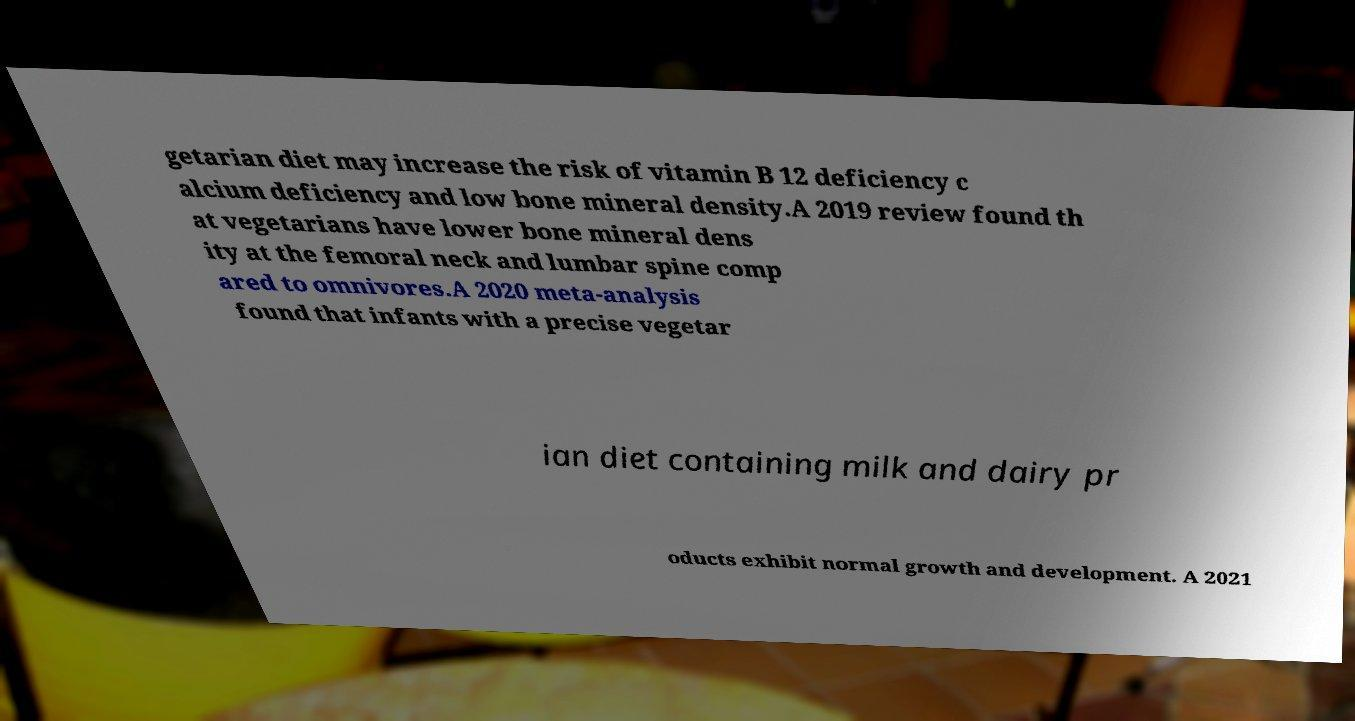Can you read and provide the text displayed in the image?This photo seems to have some interesting text. Can you extract and type it out for me? getarian diet may increase the risk of vitamin B 12 deficiency c alcium deficiency and low bone mineral density.A 2019 review found th at vegetarians have lower bone mineral dens ity at the femoral neck and lumbar spine comp ared to omnivores.A 2020 meta-analysis found that infants with a precise vegetar ian diet containing milk and dairy pr oducts exhibit normal growth and development. A 2021 